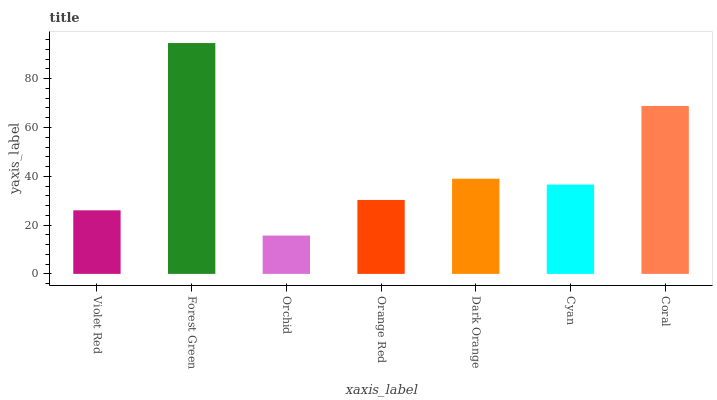Is Orchid the minimum?
Answer yes or no. Yes. Is Forest Green the maximum?
Answer yes or no. Yes. Is Forest Green the minimum?
Answer yes or no. No. Is Orchid the maximum?
Answer yes or no. No. Is Forest Green greater than Orchid?
Answer yes or no. Yes. Is Orchid less than Forest Green?
Answer yes or no. Yes. Is Orchid greater than Forest Green?
Answer yes or no. No. Is Forest Green less than Orchid?
Answer yes or no. No. Is Cyan the high median?
Answer yes or no. Yes. Is Cyan the low median?
Answer yes or no. Yes. Is Coral the high median?
Answer yes or no. No. Is Forest Green the low median?
Answer yes or no. No. 